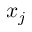<formula> <loc_0><loc_0><loc_500><loc_500>x _ { j }</formula> 